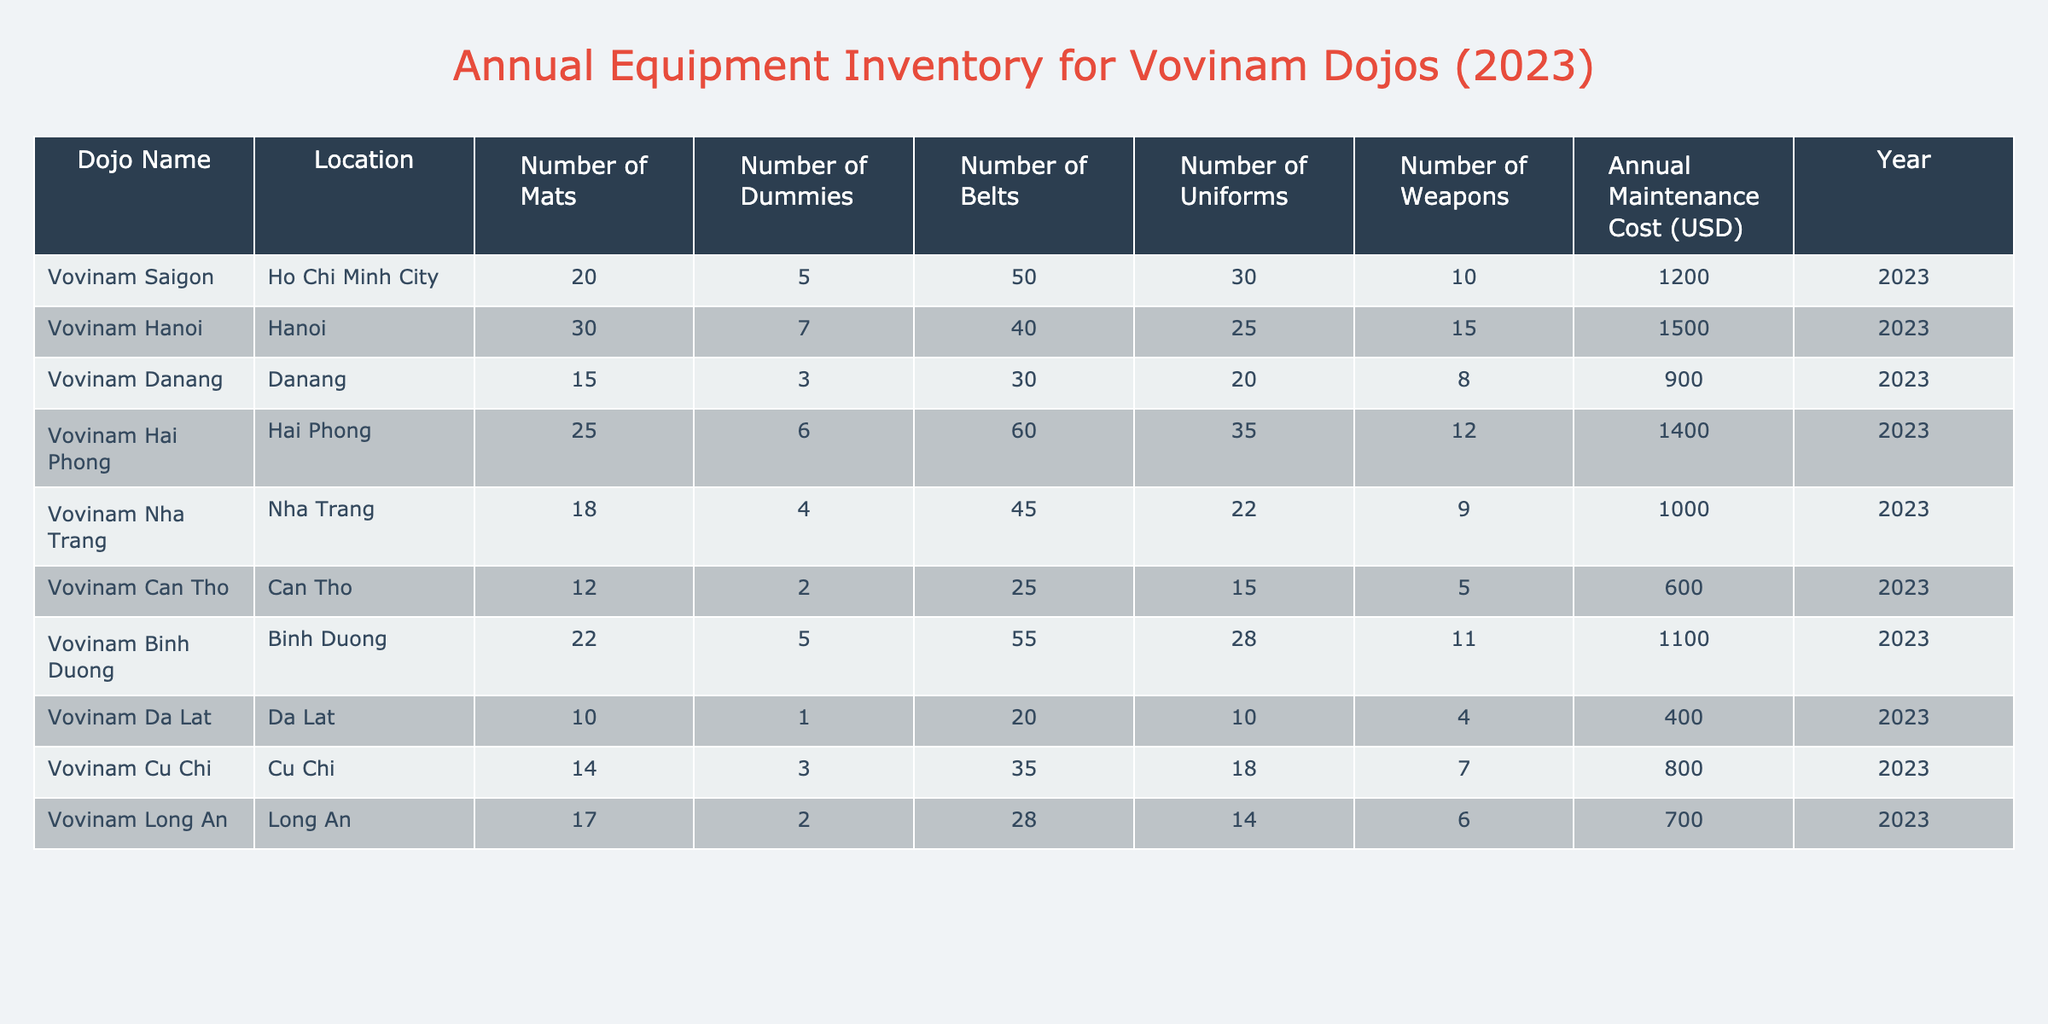What is the total number of uniforms available across all dojos? To find the total number of uniforms, we sum the uniforms from all dojos: 30 + 25 + 20 + 35 + 22 + 15 + 28 + 10 + 18 + 14 =  7 + 20 + 140 = 200
Answer: 200 Which dojo has the highest number of dummies? By looking at the dummies column, we see that Vovinam Hanoi has 7 dummies, which is the highest amount when compared to the other dojos.
Answer: Vovinam Hanoi What is the average annual maintenance cost for all dojos? To calculate the average, we sum the maintenance costs: 1200 + 1500 + 900 + 1400 + 1000 + 600 + 1100 + 400 + 800 + 700 = 8200. There are 10 dojos, so the average cost is 8200 / 10 = 820.
Answer: 820 Is it true that Vovinam Nha Trang has more uniforms than Vovinam Cu Chi? Vovinam Nha Trang has 22 uniforms, while Vovinam Cu Chi has 18 uniforms; therefore, the statement is true.
Answer: Yes Which dojo has the lowest number of mats, and how many does it have? Looking at the mats column, Vovinam Da Lat has the lowest at 10 mats compared to the others.
Answer: Vovinam Da Lat, 10 If we consider only dojos with more than 15 weapons, how many dojos are there? The dojos with more than 15 weapons are Vovinam Saigon (10), Vovinam Hanoi (15), Vovinam Hai Phong (12), Vovinam Binh Duong (11); therefore, there are no dojos fitting that criterion.
Answer: 0 What is the total count of all types of equipment in Vovinam Hai Phong? Adding all equipment for Vovinam Hai Phong gives us 25 mats + 6 dummies + 60 belts + 35 uniforms + 12 weapons = 138.
Answer: 138 Which location has the second highest annual maintenance cost? Listing the maintenance costs: 1200, 1500, 900, 1400, 1000, 600, 1100, 400, 800, 700, we see that Vovinam Hai Phong (1400) has the second highest after Hanoi (1500).
Answer: Vovinam Hai Phong What is the difference in the number of belts between the dojo with the highest and lowest belts? Vovinam Hai Phong has 60 belts (highest) and Vovinam Can Tho has 25 belts (lowest). The difference is 60 - 25 = 35.
Answer: 35 Which dojo has the most diverse set of equipment based on counts? Considering the counts of each category, Vovinam Hanoi has 30 mats, 7 dummies, 40 belts, 25 uniforms, and 15 weapons, showing a good variety across all equipment types.
Answer: Vovinam Hanoi 